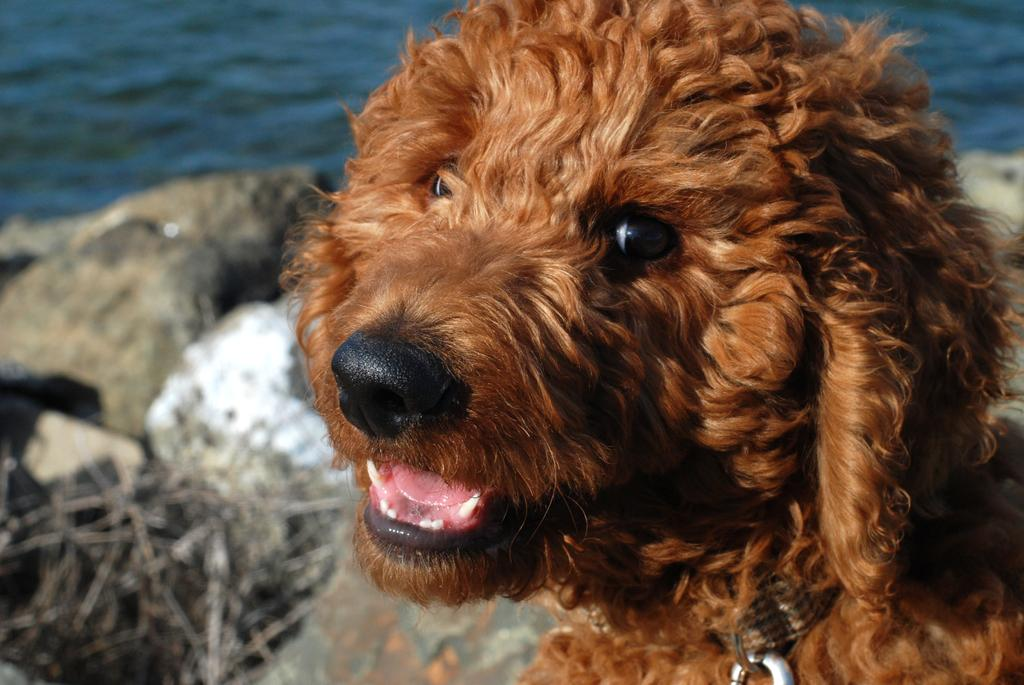What type of animal is in the image? There is a dog in the image. What color is the dog? The dog is brown in color. What can be seen on the left side of the image? There is water on the left side of the image. What type of legal advice is the dog providing in the image? The image does not depict the dog providing any legal advice, as it is a dog and not a lawyer. 